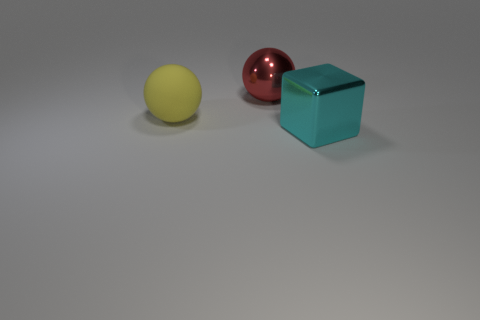Do the sphere in front of the large red object and the shiny object in front of the red metal sphere have the same size?
Ensure brevity in your answer.  Yes. What number of objects are large red metal balls or brown cylinders?
Provide a short and direct response. 1. What shape is the large matte thing?
Your response must be concise. Sphere. There is a shiny thing that is the same shape as the big yellow matte thing; what is its size?
Make the answer very short. Large. Is there anything else that has the same material as the big yellow ball?
Ensure brevity in your answer.  No. What is the size of the metallic object behind the large shiny object that is in front of the metallic sphere?
Offer a very short reply. Large. Are there the same number of large yellow rubber objects that are behind the matte ball and big gray objects?
Your answer should be compact. Yes. How many other things are there of the same color as the metallic ball?
Your answer should be compact. 0. Is the number of yellow spheres in front of the large block less than the number of rubber balls?
Your answer should be compact. Yes. Is there a purple ball of the same size as the red metallic thing?
Make the answer very short. No. 